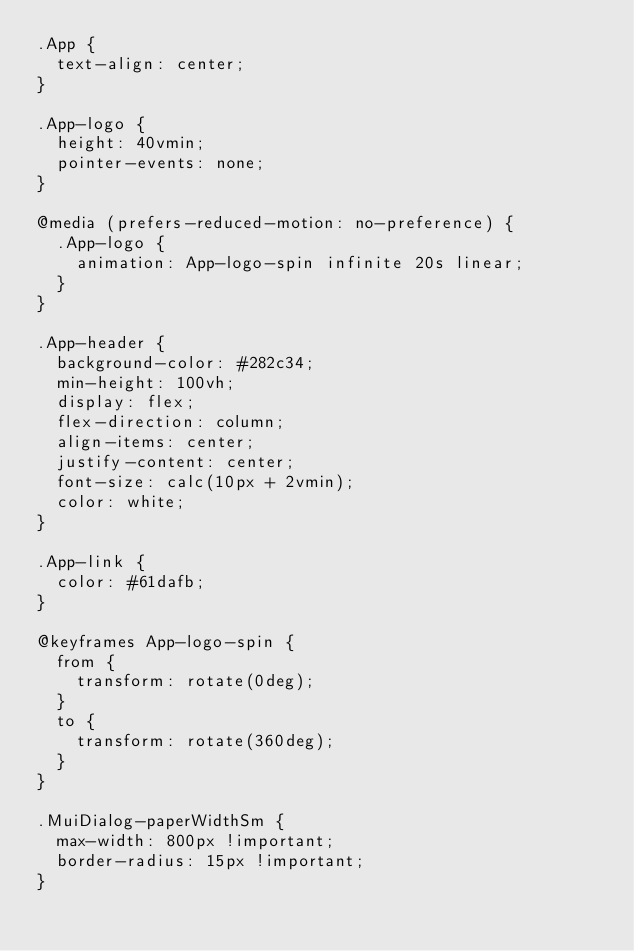<code> <loc_0><loc_0><loc_500><loc_500><_CSS_>.App {
  text-align: center;
}

.App-logo {
  height: 40vmin;
  pointer-events: none;
}

@media (prefers-reduced-motion: no-preference) {
  .App-logo {
    animation: App-logo-spin infinite 20s linear;
  }
}

.App-header {
  background-color: #282c34;
  min-height: 100vh;
  display: flex;
  flex-direction: column;
  align-items: center;
  justify-content: center;
  font-size: calc(10px + 2vmin);
  color: white;
}

.App-link {
  color: #61dafb;
}

@keyframes App-logo-spin {
  from {
    transform: rotate(0deg);
  }
  to {
    transform: rotate(360deg);
  }
}

.MuiDialog-paperWidthSm {
  max-width: 800px !important;
  border-radius: 15px !important;
}</code> 